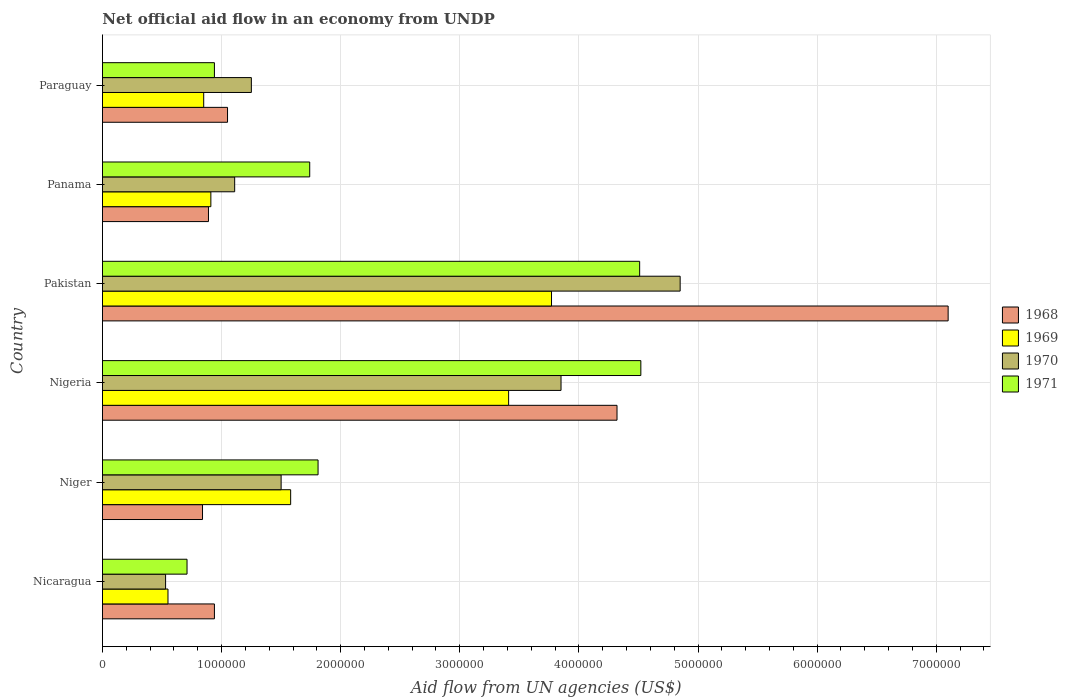How many different coloured bars are there?
Offer a terse response. 4. Are the number of bars per tick equal to the number of legend labels?
Ensure brevity in your answer.  Yes. Are the number of bars on each tick of the Y-axis equal?
Offer a very short reply. Yes. How many bars are there on the 5th tick from the top?
Give a very brief answer. 4. What is the label of the 6th group of bars from the top?
Give a very brief answer. Nicaragua. In how many cases, is the number of bars for a given country not equal to the number of legend labels?
Your answer should be very brief. 0. What is the net official aid flow in 1971 in Paraguay?
Keep it short and to the point. 9.40e+05. Across all countries, what is the maximum net official aid flow in 1970?
Keep it short and to the point. 4.85e+06. Across all countries, what is the minimum net official aid flow in 1970?
Provide a succinct answer. 5.30e+05. In which country was the net official aid flow in 1971 maximum?
Keep it short and to the point. Nigeria. In which country was the net official aid flow in 1971 minimum?
Your answer should be very brief. Nicaragua. What is the total net official aid flow in 1971 in the graph?
Keep it short and to the point. 1.42e+07. What is the difference between the net official aid flow in 1968 in Nicaragua and that in Nigeria?
Make the answer very short. -3.38e+06. What is the difference between the net official aid flow in 1968 in Nigeria and the net official aid flow in 1970 in Paraguay?
Offer a very short reply. 3.07e+06. What is the average net official aid flow in 1969 per country?
Offer a terse response. 1.84e+06. What is the difference between the net official aid flow in 1971 and net official aid flow in 1969 in Nigeria?
Your answer should be very brief. 1.11e+06. In how many countries, is the net official aid flow in 1971 greater than 6400000 US$?
Offer a terse response. 0. What is the ratio of the net official aid flow in 1969 in Nicaragua to that in Paraguay?
Provide a short and direct response. 0.65. Is the difference between the net official aid flow in 1971 in Niger and Pakistan greater than the difference between the net official aid flow in 1969 in Niger and Pakistan?
Give a very brief answer. No. What is the difference between the highest and the lowest net official aid flow in 1968?
Make the answer very short. 6.26e+06. In how many countries, is the net official aid flow in 1970 greater than the average net official aid flow in 1970 taken over all countries?
Your response must be concise. 2. What does the 1st bar from the bottom in Paraguay represents?
Ensure brevity in your answer.  1968. How many bars are there?
Offer a very short reply. 24. How are the legend labels stacked?
Your answer should be compact. Vertical. What is the title of the graph?
Offer a very short reply. Net official aid flow in an economy from UNDP. What is the label or title of the X-axis?
Give a very brief answer. Aid flow from UN agencies (US$). What is the Aid flow from UN agencies (US$) in 1968 in Nicaragua?
Offer a very short reply. 9.40e+05. What is the Aid flow from UN agencies (US$) in 1970 in Nicaragua?
Your answer should be very brief. 5.30e+05. What is the Aid flow from UN agencies (US$) of 1971 in Nicaragua?
Make the answer very short. 7.10e+05. What is the Aid flow from UN agencies (US$) of 1968 in Niger?
Provide a succinct answer. 8.40e+05. What is the Aid flow from UN agencies (US$) of 1969 in Niger?
Your answer should be compact. 1.58e+06. What is the Aid flow from UN agencies (US$) in 1970 in Niger?
Make the answer very short. 1.50e+06. What is the Aid flow from UN agencies (US$) in 1971 in Niger?
Ensure brevity in your answer.  1.81e+06. What is the Aid flow from UN agencies (US$) of 1968 in Nigeria?
Ensure brevity in your answer.  4.32e+06. What is the Aid flow from UN agencies (US$) in 1969 in Nigeria?
Your answer should be very brief. 3.41e+06. What is the Aid flow from UN agencies (US$) in 1970 in Nigeria?
Your answer should be compact. 3.85e+06. What is the Aid flow from UN agencies (US$) in 1971 in Nigeria?
Your answer should be compact. 4.52e+06. What is the Aid flow from UN agencies (US$) in 1968 in Pakistan?
Your response must be concise. 7.10e+06. What is the Aid flow from UN agencies (US$) in 1969 in Pakistan?
Keep it short and to the point. 3.77e+06. What is the Aid flow from UN agencies (US$) of 1970 in Pakistan?
Provide a short and direct response. 4.85e+06. What is the Aid flow from UN agencies (US$) of 1971 in Pakistan?
Provide a short and direct response. 4.51e+06. What is the Aid flow from UN agencies (US$) in 1968 in Panama?
Keep it short and to the point. 8.90e+05. What is the Aid flow from UN agencies (US$) of 1969 in Panama?
Ensure brevity in your answer.  9.10e+05. What is the Aid flow from UN agencies (US$) in 1970 in Panama?
Keep it short and to the point. 1.11e+06. What is the Aid flow from UN agencies (US$) of 1971 in Panama?
Provide a succinct answer. 1.74e+06. What is the Aid flow from UN agencies (US$) of 1968 in Paraguay?
Offer a very short reply. 1.05e+06. What is the Aid flow from UN agencies (US$) in 1969 in Paraguay?
Offer a terse response. 8.50e+05. What is the Aid flow from UN agencies (US$) of 1970 in Paraguay?
Provide a succinct answer. 1.25e+06. What is the Aid flow from UN agencies (US$) in 1971 in Paraguay?
Provide a short and direct response. 9.40e+05. Across all countries, what is the maximum Aid flow from UN agencies (US$) of 1968?
Offer a very short reply. 7.10e+06. Across all countries, what is the maximum Aid flow from UN agencies (US$) in 1969?
Offer a very short reply. 3.77e+06. Across all countries, what is the maximum Aid flow from UN agencies (US$) of 1970?
Offer a very short reply. 4.85e+06. Across all countries, what is the maximum Aid flow from UN agencies (US$) of 1971?
Ensure brevity in your answer.  4.52e+06. Across all countries, what is the minimum Aid flow from UN agencies (US$) in 1968?
Provide a short and direct response. 8.40e+05. Across all countries, what is the minimum Aid flow from UN agencies (US$) in 1970?
Make the answer very short. 5.30e+05. Across all countries, what is the minimum Aid flow from UN agencies (US$) in 1971?
Your response must be concise. 7.10e+05. What is the total Aid flow from UN agencies (US$) of 1968 in the graph?
Your answer should be very brief. 1.51e+07. What is the total Aid flow from UN agencies (US$) of 1969 in the graph?
Provide a succinct answer. 1.11e+07. What is the total Aid flow from UN agencies (US$) of 1970 in the graph?
Your response must be concise. 1.31e+07. What is the total Aid flow from UN agencies (US$) in 1971 in the graph?
Give a very brief answer. 1.42e+07. What is the difference between the Aid flow from UN agencies (US$) in 1968 in Nicaragua and that in Niger?
Keep it short and to the point. 1.00e+05. What is the difference between the Aid flow from UN agencies (US$) of 1969 in Nicaragua and that in Niger?
Your answer should be compact. -1.03e+06. What is the difference between the Aid flow from UN agencies (US$) of 1970 in Nicaragua and that in Niger?
Provide a succinct answer. -9.70e+05. What is the difference between the Aid flow from UN agencies (US$) in 1971 in Nicaragua and that in Niger?
Your answer should be very brief. -1.10e+06. What is the difference between the Aid flow from UN agencies (US$) of 1968 in Nicaragua and that in Nigeria?
Offer a terse response. -3.38e+06. What is the difference between the Aid flow from UN agencies (US$) in 1969 in Nicaragua and that in Nigeria?
Offer a very short reply. -2.86e+06. What is the difference between the Aid flow from UN agencies (US$) of 1970 in Nicaragua and that in Nigeria?
Offer a very short reply. -3.32e+06. What is the difference between the Aid flow from UN agencies (US$) in 1971 in Nicaragua and that in Nigeria?
Keep it short and to the point. -3.81e+06. What is the difference between the Aid flow from UN agencies (US$) in 1968 in Nicaragua and that in Pakistan?
Keep it short and to the point. -6.16e+06. What is the difference between the Aid flow from UN agencies (US$) of 1969 in Nicaragua and that in Pakistan?
Offer a terse response. -3.22e+06. What is the difference between the Aid flow from UN agencies (US$) of 1970 in Nicaragua and that in Pakistan?
Provide a short and direct response. -4.32e+06. What is the difference between the Aid flow from UN agencies (US$) of 1971 in Nicaragua and that in Pakistan?
Make the answer very short. -3.80e+06. What is the difference between the Aid flow from UN agencies (US$) of 1969 in Nicaragua and that in Panama?
Give a very brief answer. -3.60e+05. What is the difference between the Aid flow from UN agencies (US$) in 1970 in Nicaragua and that in Panama?
Your answer should be very brief. -5.80e+05. What is the difference between the Aid flow from UN agencies (US$) in 1971 in Nicaragua and that in Panama?
Your response must be concise. -1.03e+06. What is the difference between the Aid flow from UN agencies (US$) of 1969 in Nicaragua and that in Paraguay?
Ensure brevity in your answer.  -3.00e+05. What is the difference between the Aid flow from UN agencies (US$) of 1970 in Nicaragua and that in Paraguay?
Ensure brevity in your answer.  -7.20e+05. What is the difference between the Aid flow from UN agencies (US$) of 1971 in Nicaragua and that in Paraguay?
Give a very brief answer. -2.30e+05. What is the difference between the Aid flow from UN agencies (US$) of 1968 in Niger and that in Nigeria?
Offer a terse response. -3.48e+06. What is the difference between the Aid flow from UN agencies (US$) of 1969 in Niger and that in Nigeria?
Offer a very short reply. -1.83e+06. What is the difference between the Aid flow from UN agencies (US$) in 1970 in Niger and that in Nigeria?
Provide a short and direct response. -2.35e+06. What is the difference between the Aid flow from UN agencies (US$) of 1971 in Niger and that in Nigeria?
Make the answer very short. -2.71e+06. What is the difference between the Aid flow from UN agencies (US$) in 1968 in Niger and that in Pakistan?
Give a very brief answer. -6.26e+06. What is the difference between the Aid flow from UN agencies (US$) of 1969 in Niger and that in Pakistan?
Offer a very short reply. -2.19e+06. What is the difference between the Aid flow from UN agencies (US$) of 1970 in Niger and that in Pakistan?
Your response must be concise. -3.35e+06. What is the difference between the Aid flow from UN agencies (US$) in 1971 in Niger and that in Pakistan?
Keep it short and to the point. -2.70e+06. What is the difference between the Aid flow from UN agencies (US$) of 1969 in Niger and that in Panama?
Your answer should be compact. 6.70e+05. What is the difference between the Aid flow from UN agencies (US$) in 1970 in Niger and that in Panama?
Provide a succinct answer. 3.90e+05. What is the difference between the Aid flow from UN agencies (US$) of 1971 in Niger and that in Panama?
Keep it short and to the point. 7.00e+04. What is the difference between the Aid flow from UN agencies (US$) of 1968 in Niger and that in Paraguay?
Keep it short and to the point. -2.10e+05. What is the difference between the Aid flow from UN agencies (US$) of 1969 in Niger and that in Paraguay?
Offer a very short reply. 7.30e+05. What is the difference between the Aid flow from UN agencies (US$) of 1970 in Niger and that in Paraguay?
Keep it short and to the point. 2.50e+05. What is the difference between the Aid flow from UN agencies (US$) in 1971 in Niger and that in Paraguay?
Your response must be concise. 8.70e+05. What is the difference between the Aid flow from UN agencies (US$) in 1968 in Nigeria and that in Pakistan?
Ensure brevity in your answer.  -2.78e+06. What is the difference between the Aid flow from UN agencies (US$) in 1969 in Nigeria and that in Pakistan?
Offer a terse response. -3.60e+05. What is the difference between the Aid flow from UN agencies (US$) of 1968 in Nigeria and that in Panama?
Keep it short and to the point. 3.43e+06. What is the difference between the Aid flow from UN agencies (US$) in 1969 in Nigeria and that in Panama?
Provide a succinct answer. 2.50e+06. What is the difference between the Aid flow from UN agencies (US$) of 1970 in Nigeria and that in Panama?
Provide a short and direct response. 2.74e+06. What is the difference between the Aid flow from UN agencies (US$) of 1971 in Nigeria and that in Panama?
Your answer should be very brief. 2.78e+06. What is the difference between the Aid flow from UN agencies (US$) of 1968 in Nigeria and that in Paraguay?
Keep it short and to the point. 3.27e+06. What is the difference between the Aid flow from UN agencies (US$) of 1969 in Nigeria and that in Paraguay?
Ensure brevity in your answer.  2.56e+06. What is the difference between the Aid flow from UN agencies (US$) in 1970 in Nigeria and that in Paraguay?
Provide a succinct answer. 2.60e+06. What is the difference between the Aid flow from UN agencies (US$) in 1971 in Nigeria and that in Paraguay?
Provide a succinct answer. 3.58e+06. What is the difference between the Aid flow from UN agencies (US$) of 1968 in Pakistan and that in Panama?
Offer a terse response. 6.21e+06. What is the difference between the Aid flow from UN agencies (US$) of 1969 in Pakistan and that in Panama?
Provide a succinct answer. 2.86e+06. What is the difference between the Aid flow from UN agencies (US$) of 1970 in Pakistan and that in Panama?
Provide a succinct answer. 3.74e+06. What is the difference between the Aid flow from UN agencies (US$) of 1971 in Pakistan and that in Panama?
Keep it short and to the point. 2.77e+06. What is the difference between the Aid flow from UN agencies (US$) of 1968 in Pakistan and that in Paraguay?
Provide a short and direct response. 6.05e+06. What is the difference between the Aid flow from UN agencies (US$) in 1969 in Pakistan and that in Paraguay?
Your answer should be very brief. 2.92e+06. What is the difference between the Aid flow from UN agencies (US$) in 1970 in Pakistan and that in Paraguay?
Ensure brevity in your answer.  3.60e+06. What is the difference between the Aid flow from UN agencies (US$) in 1971 in Pakistan and that in Paraguay?
Ensure brevity in your answer.  3.57e+06. What is the difference between the Aid flow from UN agencies (US$) of 1968 in Panama and that in Paraguay?
Ensure brevity in your answer.  -1.60e+05. What is the difference between the Aid flow from UN agencies (US$) in 1969 in Panama and that in Paraguay?
Provide a short and direct response. 6.00e+04. What is the difference between the Aid flow from UN agencies (US$) of 1970 in Panama and that in Paraguay?
Give a very brief answer. -1.40e+05. What is the difference between the Aid flow from UN agencies (US$) in 1968 in Nicaragua and the Aid flow from UN agencies (US$) in 1969 in Niger?
Your response must be concise. -6.40e+05. What is the difference between the Aid flow from UN agencies (US$) in 1968 in Nicaragua and the Aid flow from UN agencies (US$) in 1970 in Niger?
Your answer should be compact. -5.60e+05. What is the difference between the Aid flow from UN agencies (US$) of 1968 in Nicaragua and the Aid flow from UN agencies (US$) of 1971 in Niger?
Offer a very short reply. -8.70e+05. What is the difference between the Aid flow from UN agencies (US$) in 1969 in Nicaragua and the Aid flow from UN agencies (US$) in 1970 in Niger?
Provide a succinct answer. -9.50e+05. What is the difference between the Aid flow from UN agencies (US$) in 1969 in Nicaragua and the Aid flow from UN agencies (US$) in 1971 in Niger?
Your answer should be compact. -1.26e+06. What is the difference between the Aid flow from UN agencies (US$) of 1970 in Nicaragua and the Aid flow from UN agencies (US$) of 1971 in Niger?
Offer a very short reply. -1.28e+06. What is the difference between the Aid flow from UN agencies (US$) of 1968 in Nicaragua and the Aid flow from UN agencies (US$) of 1969 in Nigeria?
Your answer should be very brief. -2.47e+06. What is the difference between the Aid flow from UN agencies (US$) of 1968 in Nicaragua and the Aid flow from UN agencies (US$) of 1970 in Nigeria?
Keep it short and to the point. -2.91e+06. What is the difference between the Aid flow from UN agencies (US$) in 1968 in Nicaragua and the Aid flow from UN agencies (US$) in 1971 in Nigeria?
Your answer should be very brief. -3.58e+06. What is the difference between the Aid flow from UN agencies (US$) of 1969 in Nicaragua and the Aid flow from UN agencies (US$) of 1970 in Nigeria?
Offer a terse response. -3.30e+06. What is the difference between the Aid flow from UN agencies (US$) of 1969 in Nicaragua and the Aid flow from UN agencies (US$) of 1971 in Nigeria?
Ensure brevity in your answer.  -3.97e+06. What is the difference between the Aid flow from UN agencies (US$) of 1970 in Nicaragua and the Aid flow from UN agencies (US$) of 1971 in Nigeria?
Your answer should be compact. -3.99e+06. What is the difference between the Aid flow from UN agencies (US$) in 1968 in Nicaragua and the Aid flow from UN agencies (US$) in 1969 in Pakistan?
Provide a succinct answer. -2.83e+06. What is the difference between the Aid flow from UN agencies (US$) in 1968 in Nicaragua and the Aid flow from UN agencies (US$) in 1970 in Pakistan?
Ensure brevity in your answer.  -3.91e+06. What is the difference between the Aid flow from UN agencies (US$) of 1968 in Nicaragua and the Aid flow from UN agencies (US$) of 1971 in Pakistan?
Give a very brief answer. -3.57e+06. What is the difference between the Aid flow from UN agencies (US$) of 1969 in Nicaragua and the Aid flow from UN agencies (US$) of 1970 in Pakistan?
Your response must be concise. -4.30e+06. What is the difference between the Aid flow from UN agencies (US$) in 1969 in Nicaragua and the Aid flow from UN agencies (US$) in 1971 in Pakistan?
Your response must be concise. -3.96e+06. What is the difference between the Aid flow from UN agencies (US$) in 1970 in Nicaragua and the Aid flow from UN agencies (US$) in 1971 in Pakistan?
Your answer should be very brief. -3.98e+06. What is the difference between the Aid flow from UN agencies (US$) of 1968 in Nicaragua and the Aid flow from UN agencies (US$) of 1969 in Panama?
Keep it short and to the point. 3.00e+04. What is the difference between the Aid flow from UN agencies (US$) in 1968 in Nicaragua and the Aid flow from UN agencies (US$) in 1971 in Panama?
Offer a terse response. -8.00e+05. What is the difference between the Aid flow from UN agencies (US$) in 1969 in Nicaragua and the Aid flow from UN agencies (US$) in 1970 in Panama?
Your answer should be compact. -5.60e+05. What is the difference between the Aid flow from UN agencies (US$) in 1969 in Nicaragua and the Aid flow from UN agencies (US$) in 1971 in Panama?
Ensure brevity in your answer.  -1.19e+06. What is the difference between the Aid flow from UN agencies (US$) of 1970 in Nicaragua and the Aid flow from UN agencies (US$) of 1971 in Panama?
Your answer should be very brief. -1.21e+06. What is the difference between the Aid flow from UN agencies (US$) of 1968 in Nicaragua and the Aid flow from UN agencies (US$) of 1969 in Paraguay?
Your answer should be compact. 9.00e+04. What is the difference between the Aid flow from UN agencies (US$) of 1968 in Nicaragua and the Aid flow from UN agencies (US$) of 1970 in Paraguay?
Offer a very short reply. -3.10e+05. What is the difference between the Aid flow from UN agencies (US$) of 1969 in Nicaragua and the Aid flow from UN agencies (US$) of 1970 in Paraguay?
Provide a succinct answer. -7.00e+05. What is the difference between the Aid flow from UN agencies (US$) of 1969 in Nicaragua and the Aid flow from UN agencies (US$) of 1971 in Paraguay?
Offer a very short reply. -3.90e+05. What is the difference between the Aid flow from UN agencies (US$) in 1970 in Nicaragua and the Aid flow from UN agencies (US$) in 1971 in Paraguay?
Keep it short and to the point. -4.10e+05. What is the difference between the Aid flow from UN agencies (US$) in 1968 in Niger and the Aid flow from UN agencies (US$) in 1969 in Nigeria?
Keep it short and to the point. -2.57e+06. What is the difference between the Aid flow from UN agencies (US$) of 1968 in Niger and the Aid flow from UN agencies (US$) of 1970 in Nigeria?
Offer a very short reply. -3.01e+06. What is the difference between the Aid flow from UN agencies (US$) of 1968 in Niger and the Aid flow from UN agencies (US$) of 1971 in Nigeria?
Make the answer very short. -3.68e+06. What is the difference between the Aid flow from UN agencies (US$) in 1969 in Niger and the Aid flow from UN agencies (US$) in 1970 in Nigeria?
Provide a succinct answer. -2.27e+06. What is the difference between the Aid flow from UN agencies (US$) of 1969 in Niger and the Aid flow from UN agencies (US$) of 1971 in Nigeria?
Provide a succinct answer. -2.94e+06. What is the difference between the Aid flow from UN agencies (US$) of 1970 in Niger and the Aid flow from UN agencies (US$) of 1971 in Nigeria?
Offer a terse response. -3.02e+06. What is the difference between the Aid flow from UN agencies (US$) of 1968 in Niger and the Aid flow from UN agencies (US$) of 1969 in Pakistan?
Offer a very short reply. -2.93e+06. What is the difference between the Aid flow from UN agencies (US$) in 1968 in Niger and the Aid flow from UN agencies (US$) in 1970 in Pakistan?
Your response must be concise. -4.01e+06. What is the difference between the Aid flow from UN agencies (US$) in 1968 in Niger and the Aid flow from UN agencies (US$) in 1971 in Pakistan?
Offer a terse response. -3.67e+06. What is the difference between the Aid flow from UN agencies (US$) of 1969 in Niger and the Aid flow from UN agencies (US$) of 1970 in Pakistan?
Offer a very short reply. -3.27e+06. What is the difference between the Aid flow from UN agencies (US$) of 1969 in Niger and the Aid flow from UN agencies (US$) of 1971 in Pakistan?
Provide a succinct answer. -2.93e+06. What is the difference between the Aid flow from UN agencies (US$) of 1970 in Niger and the Aid flow from UN agencies (US$) of 1971 in Pakistan?
Keep it short and to the point. -3.01e+06. What is the difference between the Aid flow from UN agencies (US$) in 1968 in Niger and the Aid flow from UN agencies (US$) in 1971 in Panama?
Make the answer very short. -9.00e+05. What is the difference between the Aid flow from UN agencies (US$) in 1969 in Niger and the Aid flow from UN agencies (US$) in 1970 in Panama?
Provide a succinct answer. 4.70e+05. What is the difference between the Aid flow from UN agencies (US$) of 1970 in Niger and the Aid flow from UN agencies (US$) of 1971 in Panama?
Provide a succinct answer. -2.40e+05. What is the difference between the Aid flow from UN agencies (US$) of 1968 in Niger and the Aid flow from UN agencies (US$) of 1969 in Paraguay?
Offer a terse response. -10000. What is the difference between the Aid flow from UN agencies (US$) of 1968 in Niger and the Aid flow from UN agencies (US$) of 1970 in Paraguay?
Offer a terse response. -4.10e+05. What is the difference between the Aid flow from UN agencies (US$) in 1968 in Niger and the Aid flow from UN agencies (US$) in 1971 in Paraguay?
Offer a terse response. -1.00e+05. What is the difference between the Aid flow from UN agencies (US$) of 1969 in Niger and the Aid flow from UN agencies (US$) of 1971 in Paraguay?
Offer a terse response. 6.40e+05. What is the difference between the Aid flow from UN agencies (US$) of 1970 in Niger and the Aid flow from UN agencies (US$) of 1971 in Paraguay?
Your answer should be compact. 5.60e+05. What is the difference between the Aid flow from UN agencies (US$) in 1968 in Nigeria and the Aid flow from UN agencies (US$) in 1970 in Pakistan?
Make the answer very short. -5.30e+05. What is the difference between the Aid flow from UN agencies (US$) of 1968 in Nigeria and the Aid flow from UN agencies (US$) of 1971 in Pakistan?
Ensure brevity in your answer.  -1.90e+05. What is the difference between the Aid flow from UN agencies (US$) in 1969 in Nigeria and the Aid flow from UN agencies (US$) in 1970 in Pakistan?
Offer a very short reply. -1.44e+06. What is the difference between the Aid flow from UN agencies (US$) in 1969 in Nigeria and the Aid flow from UN agencies (US$) in 1971 in Pakistan?
Make the answer very short. -1.10e+06. What is the difference between the Aid flow from UN agencies (US$) in 1970 in Nigeria and the Aid flow from UN agencies (US$) in 1971 in Pakistan?
Make the answer very short. -6.60e+05. What is the difference between the Aid flow from UN agencies (US$) in 1968 in Nigeria and the Aid flow from UN agencies (US$) in 1969 in Panama?
Provide a succinct answer. 3.41e+06. What is the difference between the Aid flow from UN agencies (US$) in 1968 in Nigeria and the Aid flow from UN agencies (US$) in 1970 in Panama?
Your response must be concise. 3.21e+06. What is the difference between the Aid flow from UN agencies (US$) in 1968 in Nigeria and the Aid flow from UN agencies (US$) in 1971 in Panama?
Offer a very short reply. 2.58e+06. What is the difference between the Aid flow from UN agencies (US$) in 1969 in Nigeria and the Aid flow from UN agencies (US$) in 1970 in Panama?
Provide a succinct answer. 2.30e+06. What is the difference between the Aid flow from UN agencies (US$) of 1969 in Nigeria and the Aid flow from UN agencies (US$) of 1971 in Panama?
Provide a short and direct response. 1.67e+06. What is the difference between the Aid flow from UN agencies (US$) of 1970 in Nigeria and the Aid flow from UN agencies (US$) of 1971 in Panama?
Your answer should be very brief. 2.11e+06. What is the difference between the Aid flow from UN agencies (US$) in 1968 in Nigeria and the Aid flow from UN agencies (US$) in 1969 in Paraguay?
Offer a very short reply. 3.47e+06. What is the difference between the Aid flow from UN agencies (US$) of 1968 in Nigeria and the Aid flow from UN agencies (US$) of 1970 in Paraguay?
Make the answer very short. 3.07e+06. What is the difference between the Aid flow from UN agencies (US$) in 1968 in Nigeria and the Aid flow from UN agencies (US$) in 1971 in Paraguay?
Provide a short and direct response. 3.38e+06. What is the difference between the Aid flow from UN agencies (US$) of 1969 in Nigeria and the Aid flow from UN agencies (US$) of 1970 in Paraguay?
Your answer should be very brief. 2.16e+06. What is the difference between the Aid flow from UN agencies (US$) of 1969 in Nigeria and the Aid flow from UN agencies (US$) of 1971 in Paraguay?
Provide a succinct answer. 2.47e+06. What is the difference between the Aid flow from UN agencies (US$) of 1970 in Nigeria and the Aid flow from UN agencies (US$) of 1971 in Paraguay?
Make the answer very short. 2.91e+06. What is the difference between the Aid flow from UN agencies (US$) in 1968 in Pakistan and the Aid flow from UN agencies (US$) in 1969 in Panama?
Ensure brevity in your answer.  6.19e+06. What is the difference between the Aid flow from UN agencies (US$) of 1968 in Pakistan and the Aid flow from UN agencies (US$) of 1970 in Panama?
Give a very brief answer. 5.99e+06. What is the difference between the Aid flow from UN agencies (US$) in 1968 in Pakistan and the Aid flow from UN agencies (US$) in 1971 in Panama?
Your response must be concise. 5.36e+06. What is the difference between the Aid flow from UN agencies (US$) in 1969 in Pakistan and the Aid flow from UN agencies (US$) in 1970 in Panama?
Provide a short and direct response. 2.66e+06. What is the difference between the Aid flow from UN agencies (US$) in 1969 in Pakistan and the Aid flow from UN agencies (US$) in 1971 in Panama?
Your response must be concise. 2.03e+06. What is the difference between the Aid flow from UN agencies (US$) in 1970 in Pakistan and the Aid flow from UN agencies (US$) in 1971 in Panama?
Keep it short and to the point. 3.11e+06. What is the difference between the Aid flow from UN agencies (US$) of 1968 in Pakistan and the Aid flow from UN agencies (US$) of 1969 in Paraguay?
Your response must be concise. 6.25e+06. What is the difference between the Aid flow from UN agencies (US$) in 1968 in Pakistan and the Aid flow from UN agencies (US$) in 1970 in Paraguay?
Keep it short and to the point. 5.85e+06. What is the difference between the Aid flow from UN agencies (US$) of 1968 in Pakistan and the Aid flow from UN agencies (US$) of 1971 in Paraguay?
Provide a short and direct response. 6.16e+06. What is the difference between the Aid flow from UN agencies (US$) of 1969 in Pakistan and the Aid flow from UN agencies (US$) of 1970 in Paraguay?
Offer a very short reply. 2.52e+06. What is the difference between the Aid flow from UN agencies (US$) of 1969 in Pakistan and the Aid flow from UN agencies (US$) of 1971 in Paraguay?
Make the answer very short. 2.83e+06. What is the difference between the Aid flow from UN agencies (US$) of 1970 in Pakistan and the Aid flow from UN agencies (US$) of 1971 in Paraguay?
Your response must be concise. 3.91e+06. What is the difference between the Aid flow from UN agencies (US$) in 1968 in Panama and the Aid flow from UN agencies (US$) in 1970 in Paraguay?
Provide a succinct answer. -3.60e+05. What is the difference between the Aid flow from UN agencies (US$) of 1968 in Panama and the Aid flow from UN agencies (US$) of 1971 in Paraguay?
Provide a short and direct response. -5.00e+04. What is the difference between the Aid flow from UN agencies (US$) of 1969 in Panama and the Aid flow from UN agencies (US$) of 1971 in Paraguay?
Keep it short and to the point. -3.00e+04. What is the average Aid flow from UN agencies (US$) in 1968 per country?
Keep it short and to the point. 2.52e+06. What is the average Aid flow from UN agencies (US$) of 1969 per country?
Offer a terse response. 1.84e+06. What is the average Aid flow from UN agencies (US$) in 1970 per country?
Your response must be concise. 2.18e+06. What is the average Aid flow from UN agencies (US$) in 1971 per country?
Provide a short and direct response. 2.37e+06. What is the difference between the Aid flow from UN agencies (US$) in 1968 and Aid flow from UN agencies (US$) in 1969 in Nicaragua?
Give a very brief answer. 3.90e+05. What is the difference between the Aid flow from UN agencies (US$) in 1968 and Aid flow from UN agencies (US$) in 1971 in Nicaragua?
Your answer should be very brief. 2.30e+05. What is the difference between the Aid flow from UN agencies (US$) of 1969 and Aid flow from UN agencies (US$) of 1970 in Nicaragua?
Make the answer very short. 2.00e+04. What is the difference between the Aid flow from UN agencies (US$) of 1970 and Aid flow from UN agencies (US$) of 1971 in Nicaragua?
Provide a succinct answer. -1.80e+05. What is the difference between the Aid flow from UN agencies (US$) of 1968 and Aid flow from UN agencies (US$) of 1969 in Niger?
Your answer should be very brief. -7.40e+05. What is the difference between the Aid flow from UN agencies (US$) of 1968 and Aid flow from UN agencies (US$) of 1970 in Niger?
Keep it short and to the point. -6.60e+05. What is the difference between the Aid flow from UN agencies (US$) of 1968 and Aid flow from UN agencies (US$) of 1971 in Niger?
Your response must be concise. -9.70e+05. What is the difference between the Aid flow from UN agencies (US$) of 1969 and Aid flow from UN agencies (US$) of 1970 in Niger?
Provide a short and direct response. 8.00e+04. What is the difference between the Aid flow from UN agencies (US$) of 1969 and Aid flow from UN agencies (US$) of 1971 in Niger?
Provide a short and direct response. -2.30e+05. What is the difference between the Aid flow from UN agencies (US$) of 1970 and Aid flow from UN agencies (US$) of 1971 in Niger?
Offer a terse response. -3.10e+05. What is the difference between the Aid flow from UN agencies (US$) of 1968 and Aid flow from UN agencies (US$) of 1969 in Nigeria?
Keep it short and to the point. 9.10e+05. What is the difference between the Aid flow from UN agencies (US$) of 1968 and Aid flow from UN agencies (US$) of 1970 in Nigeria?
Ensure brevity in your answer.  4.70e+05. What is the difference between the Aid flow from UN agencies (US$) of 1969 and Aid flow from UN agencies (US$) of 1970 in Nigeria?
Keep it short and to the point. -4.40e+05. What is the difference between the Aid flow from UN agencies (US$) of 1969 and Aid flow from UN agencies (US$) of 1971 in Nigeria?
Make the answer very short. -1.11e+06. What is the difference between the Aid flow from UN agencies (US$) in 1970 and Aid flow from UN agencies (US$) in 1971 in Nigeria?
Provide a succinct answer. -6.70e+05. What is the difference between the Aid flow from UN agencies (US$) of 1968 and Aid flow from UN agencies (US$) of 1969 in Pakistan?
Offer a terse response. 3.33e+06. What is the difference between the Aid flow from UN agencies (US$) of 1968 and Aid flow from UN agencies (US$) of 1970 in Pakistan?
Provide a short and direct response. 2.25e+06. What is the difference between the Aid flow from UN agencies (US$) in 1968 and Aid flow from UN agencies (US$) in 1971 in Pakistan?
Keep it short and to the point. 2.59e+06. What is the difference between the Aid flow from UN agencies (US$) of 1969 and Aid flow from UN agencies (US$) of 1970 in Pakistan?
Make the answer very short. -1.08e+06. What is the difference between the Aid flow from UN agencies (US$) in 1969 and Aid flow from UN agencies (US$) in 1971 in Pakistan?
Ensure brevity in your answer.  -7.40e+05. What is the difference between the Aid flow from UN agencies (US$) of 1970 and Aid flow from UN agencies (US$) of 1971 in Pakistan?
Provide a succinct answer. 3.40e+05. What is the difference between the Aid flow from UN agencies (US$) in 1968 and Aid flow from UN agencies (US$) in 1969 in Panama?
Your answer should be very brief. -2.00e+04. What is the difference between the Aid flow from UN agencies (US$) of 1968 and Aid flow from UN agencies (US$) of 1970 in Panama?
Your answer should be very brief. -2.20e+05. What is the difference between the Aid flow from UN agencies (US$) of 1968 and Aid flow from UN agencies (US$) of 1971 in Panama?
Your answer should be very brief. -8.50e+05. What is the difference between the Aid flow from UN agencies (US$) in 1969 and Aid flow from UN agencies (US$) in 1971 in Panama?
Ensure brevity in your answer.  -8.30e+05. What is the difference between the Aid flow from UN agencies (US$) in 1970 and Aid flow from UN agencies (US$) in 1971 in Panama?
Provide a short and direct response. -6.30e+05. What is the difference between the Aid flow from UN agencies (US$) of 1968 and Aid flow from UN agencies (US$) of 1969 in Paraguay?
Offer a very short reply. 2.00e+05. What is the difference between the Aid flow from UN agencies (US$) of 1969 and Aid flow from UN agencies (US$) of 1970 in Paraguay?
Offer a very short reply. -4.00e+05. What is the difference between the Aid flow from UN agencies (US$) in 1969 and Aid flow from UN agencies (US$) in 1971 in Paraguay?
Make the answer very short. -9.00e+04. What is the difference between the Aid flow from UN agencies (US$) of 1970 and Aid flow from UN agencies (US$) of 1971 in Paraguay?
Make the answer very short. 3.10e+05. What is the ratio of the Aid flow from UN agencies (US$) in 1968 in Nicaragua to that in Niger?
Your answer should be very brief. 1.12. What is the ratio of the Aid flow from UN agencies (US$) of 1969 in Nicaragua to that in Niger?
Provide a succinct answer. 0.35. What is the ratio of the Aid flow from UN agencies (US$) in 1970 in Nicaragua to that in Niger?
Keep it short and to the point. 0.35. What is the ratio of the Aid flow from UN agencies (US$) of 1971 in Nicaragua to that in Niger?
Keep it short and to the point. 0.39. What is the ratio of the Aid flow from UN agencies (US$) of 1968 in Nicaragua to that in Nigeria?
Your response must be concise. 0.22. What is the ratio of the Aid flow from UN agencies (US$) of 1969 in Nicaragua to that in Nigeria?
Keep it short and to the point. 0.16. What is the ratio of the Aid flow from UN agencies (US$) of 1970 in Nicaragua to that in Nigeria?
Make the answer very short. 0.14. What is the ratio of the Aid flow from UN agencies (US$) of 1971 in Nicaragua to that in Nigeria?
Provide a short and direct response. 0.16. What is the ratio of the Aid flow from UN agencies (US$) in 1968 in Nicaragua to that in Pakistan?
Your response must be concise. 0.13. What is the ratio of the Aid flow from UN agencies (US$) in 1969 in Nicaragua to that in Pakistan?
Make the answer very short. 0.15. What is the ratio of the Aid flow from UN agencies (US$) of 1970 in Nicaragua to that in Pakistan?
Your response must be concise. 0.11. What is the ratio of the Aid flow from UN agencies (US$) in 1971 in Nicaragua to that in Pakistan?
Provide a succinct answer. 0.16. What is the ratio of the Aid flow from UN agencies (US$) in 1968 in Nicaragua to that in Panama?
Your answer should be compact. 1.06. What is the ratio of the Aid flow from UN agencies (US$) of 1969 in Nicaragua to that in Panama?
Give a very brief answer. 0.6. What is the ratio of the Aid flow from UN agencies (US$) in 1970 in Nicaragua to that in Panama?
Your answer should be very brief. 0.48. What is the ratio of the Aid flow from UN agencies (US$) in 1971 in Nicaragua to that in Panama?
Your answer should be very brief. 0.41. What is the ratio of the Aid flow from UN agencies (US$) of 1968 in Nicaragua to that in Paraguay?
Give a very brief answer. 0.9. What is the ratio of the Aid flow from UN agencies (US$) of 1969 in Nicaragua to that in Paraguay?
Your response must be concise. 0.65. What is the ratio of the Aid flow from UN agencies (US$) in 1970 in Nicaragua to that in Paraguay?
Give a very brief answer. 0.42. What is the ratio of the Aid flow from UN agencies (US$) in 1971 in Nicaragua to that in Paraguay?
Keep it short and to the point. 0.76. What is the ratio of the Aid flow from UN agencies (US$) of 1968 in Niger to that in Nigeria?
Give a very brief answer. 0.19. What is the ratio of the Aid flow from UN agencies (US$) in 1969 in Niger to that in Nigeria?
Your response must be concise. 0.46. What is the ratio of the Aid flow from UN agencies (US$) in 1970 in Niger to that in Nigeria?
Give a very brief answer. 0.39. What is the ratio of the Aid flow from UN agencies (US$) in 1971 in Niger to that in Nigeria?
Offer a terse response. 0.4. What is the ratio of the Aid flow from UN agencies (US$) in 1968 in Niger to that in Pakistan?
Offer a terse response. 0.12. What is the ratio of the Aid flow from UN agencies (US$) in 1969 in Niger to that in Pakistan?
Your answer should be very brief. 0.42. What is the ratio of the Aid flow from UN agencies (US$) in 1970 in Niger to that in Pakistan?
Provide a succinct answer. 0.31. What is the ratio of the Aid flow from UN agencies (US$) in 1971 in Niger to that in Pakistan?
Make the answer very short. 0.4. What is the ratio of the Aid flow from UN agencies (US$) of 1968 in Niger to that in Panama?
Ensure brevity in your answer.  0.94. What is the ratio of the Aid flow from UN agencies (US$) of 1969 in Niger to that in Panama?
Your response must be concise. 1.74. What is the ratio of the Aid flow from UN agencies (US$) of 1970 in Niger to that in Panama?
Give a very brief answer. 1.35. What is the ratio of the Aid flow from UN agencies (US$) in 1971 in Niger to that in Panama?
Make the answer very short. 1.04. What is the ratio of the Aid flow from UN agencies (US$) of 1969 in Niger to that in Paraguay?
Ensure brevity in your answer.  1.86. What is the ratio of the Aid flow from UN agencies (US$) of 1971 in Niger to that in Paraguay?
Offer a terse response. 1.93. What is the ratio of the Aid flow from UN agencies (US$) of 1968 in Nigeria to that in Pakistan?
Provide a short and direct response. 0.61. What is the ratio of the Aid flow from UN agencies (US$) in 1969 in Nigeria to that in Pakistan?
Provide a short and direct response. 0.9. What is the ratio of the Aid flow from UN agencies (US$) in 1970 in Nigeria to that in Pakistan?
Provide a succinct answer. 0.79. What is the ratio of the Aid flow from UN agencies (US$) in 1968 in Nigeria to that in Panama?
Offer a terse response. 4.85. What is the ratio of the Aid flow from UN agencies (US$) of 1969 in Nigeria to that in Panama?
Your answer should be very brief. 3.75. What is the ratio of the Aid flow from UN agencies (US$) of 1970 in Nigeria to that in Panama?
Offer a very short reply. 3.47. What is the ratio of the Aid flow from UN agencies (US$) in 1971 in Nigeria to that in Panama?
Offer a terse response. 2.6. What is the ratio of the Aid flow from UN agencies (US$) in 1968 in Nigeria to that in Paraguay?
Offer a very short reply. 4.11. What is the ratio of the Aid flow from UN agencies (US$) in 1969 in Nigeria to that in Paraguay?
Your response must be concise. 4.01. What is the ratio of the Aid flow from UN agencies (US$) in 1970 in Nigeria to that in Paraguay?
Provide a succinct answer. 3.08. What is the ratio of the Aid flow from UN agencies (US$) in 1971 in Nigeria to that in Paraguay?
Your answer should be very brief. 4.81. What is the ratio of the Aid flow from UN agencies (US$) of 1968 in Pakistan to that in Panama?
Offer a terse response. 7.98. What is the ratio of the Aid flow from UN agencies (US$) in 1969 in Pakistan to that in Panama?
Keep it short and to the point. 4.14. What is the ratio of the Aid flow from UN agencies (US$) in 1970 in Pakistan to that in Panama?
Make the answer very short. 4.37. What is the ratio of the Aid flow from UN agencies (US$) in 1971 in Pakistan to that in Panama?
Offer a terse response. 2.59. What is the ratio of the Aid flow from UN agencies (US$) of 1968 in Pakistan to that in Paraguay?
Offer a terse response. 6.76. What is the ratio of the Aid flow from UN agencies (US$) of 1969 in Pakistan to that in Paraguay?
Your answer should be very brief. 4.44. What is the ratio of the Aid flow from UN agencies (US$) of 1970 in Pakistan to that in Paraguay?
Provide a succinct answer. 3.88. What is the ratio of the Aid flow from UN agencies (US$) in 1971 in Pakistan to that in Paraguay?
Your answer should be very brief. 4.8. What is the ratio of the Aid flow from UN agencies (US$) of 1968 in Panama to that in Paraguay?
Keep it short and to the point. 0.85. What is the ratio of the Aid flow from UN agencies (US$) in 1969 in Panama to that in Paraguay?
Give a very brief answer. 1.07. What is the ratio of the Aid flow from UN agencies (US$) in 1970 in Panama to that in Paraguay?
Offer a terse response. 0.89. What is the ratio of the Aid flow from UN agencies (US$) of 1971 in Panama to that in Paraguay?
Give a very brief answer. 1.85. What is the difference between the highest and the second highest Aid flow from UN agencies (US$) of 1968?
Offer a very short reply. 2.78e+06. What is the difference between the highest and the second highest Aid flow from UN agencies (US$) of 1969?
Offer a terse response. 3.60e+05. What is the difference between the highest and the second highest Aid flow from UN agencies (US$) in 1971?
Ensure brevity in your answer.  10000. What is the difference between the highest and the lowest Aid flow from UN agencies (US$) of 1968?
Your answer should be compact. 6.26e+06. What is the difference between the highest and the lowest Aid flow from UN agencies (US$) of 1969?
Offer a very short reply. 3.22e+06. What is the difference between the highest and the lowest Aid flow from UN agencies (US$) in 1970?
Provide a succinct answer. 4.32e+06. What is the difference between the highest and the lowest Aid flow from UN agencies (US$) in 1971?
Your answer should be very brief. 3.81e+06. 